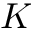Convert formula to latex. <formula><loc_0><loc_0><loc_500><loc_500>K</formula> 